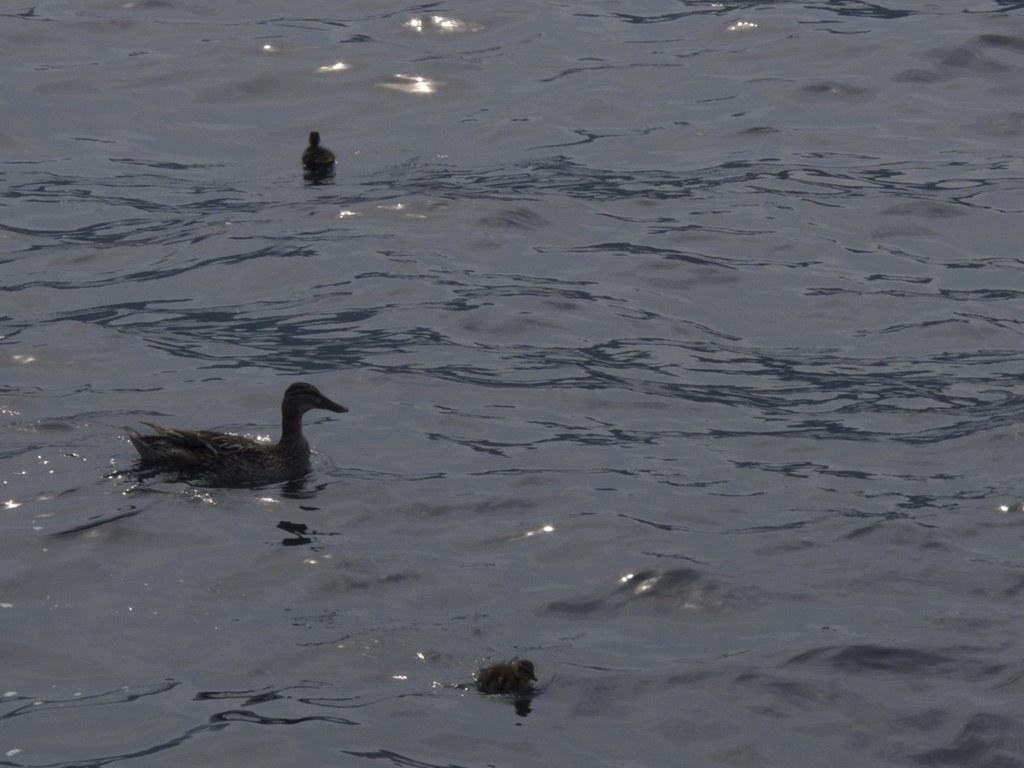How many birds are in the image? There are three birds in the image. What are the birds doing in the image? The birds are swimming in the water. What is the primary element in which the birds are situated? The birds are swimming in water, which is visible in the image. What type of account can be seen in the image? There is no account present in the image; it features three birds swimming in water. How many corks are floating in the water in the image? There are no corks visible in the image; it only features three birds swimming in water. 